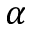<formula> <loc_0><loc_0><loc_500><loc_500>\alpha</formula> 